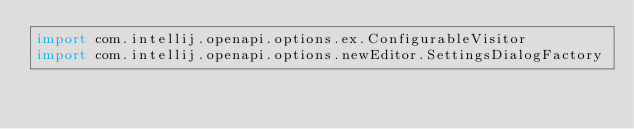Convert code to text. <code><loc_0><loc_0><loc_500><loc_500><_Kotlin_>import com.intellij.openapi.options.ex.ConfigurableVisitor
import com.intellij.openapi.options.newEditor.SettingsDialogFactory</code> 